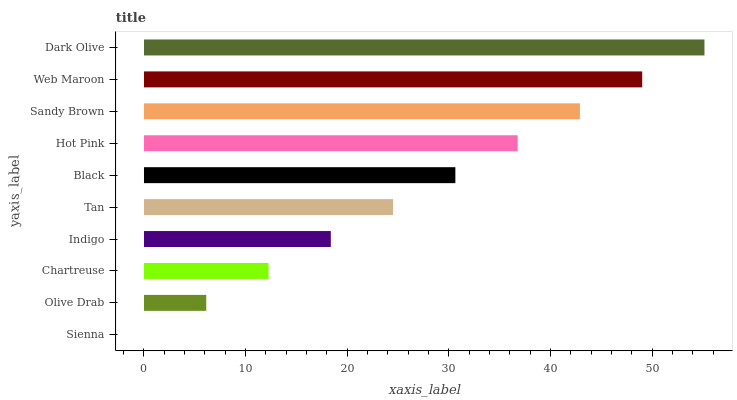Is Sienna the minimum?
Answer yes or no. Yes. Is Dark Olive the maximum?
Answer yes or no. Yes. Is Olive Drab the minimum?
Answer yes or no. No. Is Olive Drab the maximum?
Answer yes or no. No. Is Olive Drab greater than Sienna?
Answer yes or no. Yes. Is Sienna less than Olive Drab?
Answer yes or no. Yes. Is Sienna greater than Olive Drab?
Answer yes or no. No. Is Olive Drab less than Sienna?
Answer yes or no. No. Is Black the high median?
Answer yes or no. Yes. Is Tan the low median?
Answer yes or no. Yes. Is Hot Pink the high median?
Answer yes or no. No. Is Olive Drab the low median?
Answer yes or no. No. 